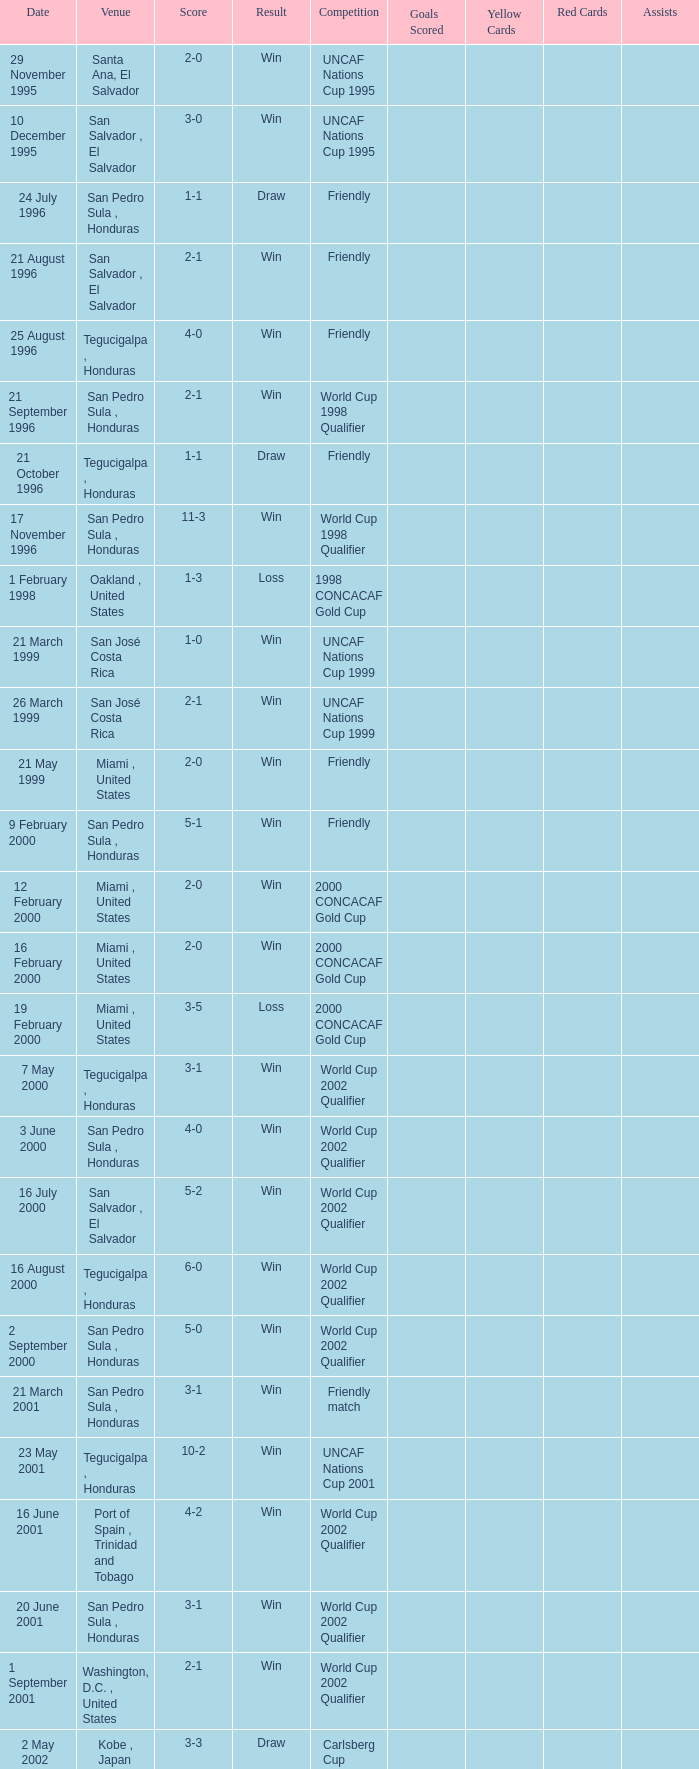Which place hosted the friendly contest that ended in a 4-0 result? Tegucigalpa , Honduras. Can you parse all the data within this table? {'header': ['Date', 'Venue', 'Score', 'Result', 'Competition', 'Goals Scored', 'Yellow Cards', 'Red Cards', 'Assists'], 'rows': [['29 November 1995', 'Santa Ana, El Salvador', '2-0', 'Win', 'UNCAF Nations Cup 1995', '', '', '', ''], ['10 December 1995', 'San Salvador , El Salvador', '3-0', 'Win', 'UNCAF Nations Cup 1995', '', '', '', ''], ['24 July 1996', 'San Pedro Sula , Honduras', '1-1', 'Draw', 'Friendly', '', '', '', ''], ['21 August 1996', 'San Salvador , El Salvador', '2-1', 'Win', 'Friendly', '', '', '', ''], ['25 August 1996', 'Tegucigalpa , Honduras', '4-0', 'Win', 'Friendly', '', '', '', ''], ['21 September 1996', 'San Pedro Sula , Honduras', '2-1', 'Win', 'World Cup 1998 Qualifier', '', '', '', ''], ['21 October 1996', 'Tegucigalpa , Honduras', '1-1', 'Draw', 'Friendly', '', '', '', ''], ['17 November 1996', 'San Pedro Sula , Honduras', '11-3', 'Win', 'World Cup 1998 Qualifier', '', '', '', ''], ['1 February 1998', 'Oakland , United States', '1-3', 'Loss', '1998 CONCACAF Gold Cup', '', '', '', ''], ['21 March 1999', 'San José Costa Rica', '1-0', 'Win', 'UNCAF Nations Cup 1999', '', '', '', ''], ['26 March 1999', 'San José Costa Rica', '2-1', 'Win', 'UNCAF Nations Cup 1999', '', '', '', ''], ['21 May 1999', 'Miami , United States', '2-0', 'Win', 'Friendly', '', '', '', ''], ['9 February 2000', 'San Pedro Sula , Honduras', '5-1', 'Win', 'Friendly', '', '', '', ''], ['12 February 2000', 'Miami , United States', '2-0', 'Win', '2000 CONCACAF Gold Cup', '', '', '', ''], ['16 February 2000', 'Miami , United States', '2-0', 'Win', '2000 CONCACAF Gold Cup', '', '', '', ''], ['19 February 2000', 'Miami , United States', '3-5', 'Loss', '2000 CONCACAF Gold Cup', '', '', '', ''], ['7 May 2000', 'Tegucigalpa , Honduras', '3-1', 'Win', 'World Cup 2002 Qualifier', '', '', '', ''], ['3 June 2000', 'San Pedro Sula , Honduras', '4-0', 'Win', 'World Cup 2002 Qualifier', '', '', '', ''], ['16 July 2000', 'San Salvador , El Salvador', '5-2', 'Win', 'World Cup 2002 Qualifier', '', '', '', ''], ['16 August 2000', 'Tegucigalpa , Honduras', '6-0', 'Win', 'World Cup 2002 Qualifier', '', '', '', ''], ['2 September 2000', 'San Pedro Sula , Honduras', '5-0', 'Win', 'World Cup 2002 Qualifier', '', '', '', ''], ['21 March 2001', 'San Pedro Sula , Honduras', '3-1', 'Win', 'Friendly match', '', '', '', ''], ['23 May 2001', 'Tegucigalpa , Honduras', '10-2', 'Win', 'UNCAF Nations Cup 2001', '', '', '', ''], ['16 June 2001', 'Port of Spain , Trinidad and Tobago', '4-2', 'Win', 'World Cup 2002 Qualifier', '', '', '', ''], ['20 June 2001', 'San Pedro Sula , Honduras', '3-1', 'Win', 'World Cup 2002 Qualifier', '', '', '', ''], ['1 September 2001', 'Washington, D.C. , United States', '2-1', 'Win', 'World Cup 2002 Qualifier', '', '', '', ''], ['2 May 2002', 'Kobe , Japan', '3-3', 'Draw', 'Carlsberg Cup', '', '', '', ''], ['28 April 2004', 'Fort Lauderdale , United States', '1-1', 'Draw', 'Friendly', '', '', '', ''], ['19 June 2004', 'San Pedro Sula , Honduras', '4-0', 'Win', 'World Cup 2006 Qualification', '', '', '', ''], ['19 April 2007', 'La Ceiba , Honduras', '1-3', 'Loss', 'Friendly', '', '', '', ''], ['25 May 2007', 'Mérida , Venezuela', '1-2', 'Loss', 'Friendly', '', '', '', ''], ['13 June 2007', 'Houston , United States', '5-0', 'Win', '2007 CONCACAF Gold Cup', '', '', '', ''], ['17 June 2007', 'Houston , United States', '1-2', 'Loss', '2007 CONCACAF Gold Cup', '', '', '', ''], ['18 January 2009', 'Miami , United States', '2-0', 'Win', 'Friendly', '', '', '', ''], ['26 January 2009', 'Tegucigalpa , Honduras', '2-0', 'Win', 'UNCAF Nations Cup 2009', '', '', '', ''], ['28 March 2009', 'Port of Spain , Trinidad and Tobago', '1-1', 'Draw', 'World Cup 2010 Qualification', '', '', '', ''], ['1 April 2009', 'San Pedro Sula , Honduras', '3-1', 'Win', 'World Cup 2010 Qualification', '', '', '', ''], ['10 June 2009', 'San Pedro Sula , Honduras', '1-0', 'Win', 'World Cup 2010 Qualification', '', '', '', ''], ['12 August 2009', 'San Pedro Sula , Honduras', '4-0', 'Win', 'World Cup 2010 Qualification', '', '', '', ''], ['5 September 2009', 'San Pedro Sula , Honduras', '4-1', 'Win', 'World Cup 2010 Qualification', '', '', '', ''], ['14 October 2009', 'San Salvador , El Salvador', '1-0', 'Win', 'World Cup 2010 Qualification', '', '', '', ''], ['23 January 2010', 'Carson , United States', '3-1', 'Win', 'Friendly', '', '', '', '']]} 